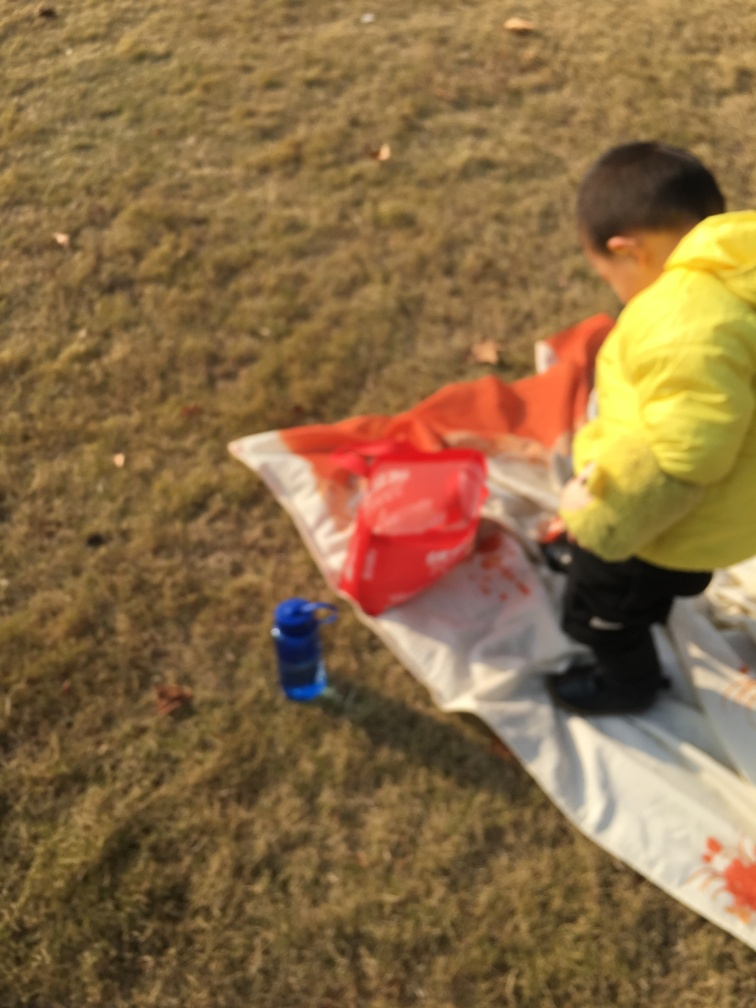Can you comment on the time of day or season it might be? The lighting in the image suggests it's daytime, and the attire of the child, which includes a jacket, might indicate it's either autumn or spring when the weather is cool but not cold. Based on the image, does the child seem to be alone? While the child appears to be the only person in the frame, it is likely that an adult or guardian is nearby, potentially taking the photo or supervising the child's activities. 